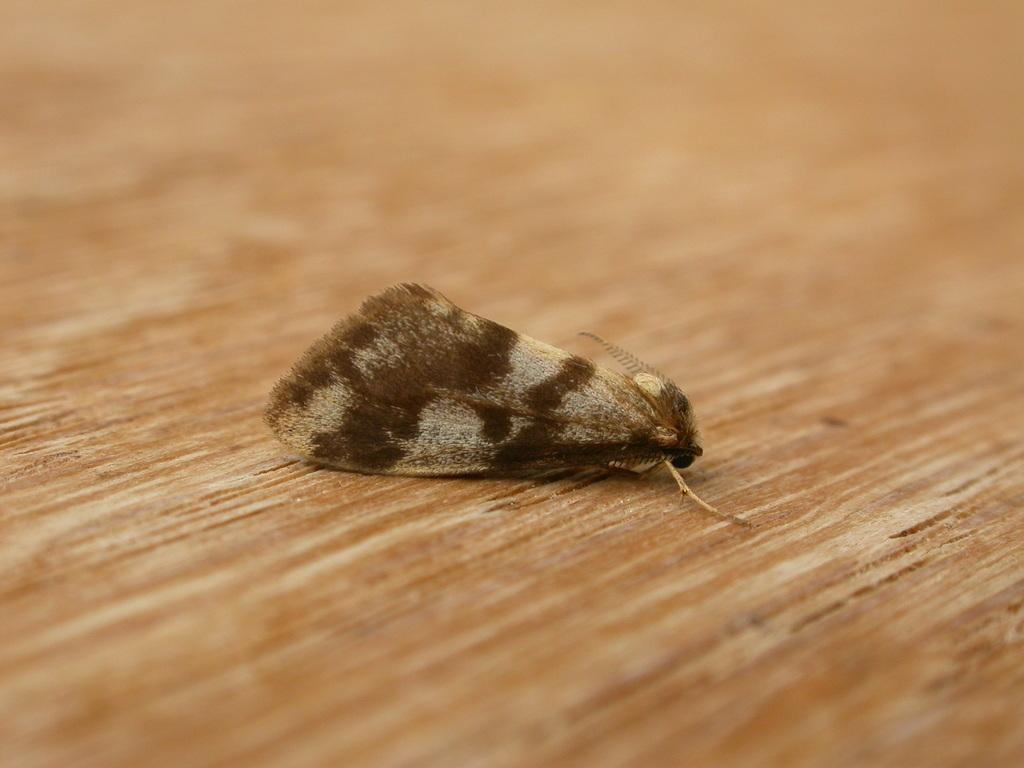What type of insect is present in the image? There is a brown butterfly in the image. Where is the butterfly located? The butterfly is sitting on a wooden table top. What type of toothbrush is the butterfly using in the image? There is no toothbrush present in the image, and the butterfly is not using any object. 